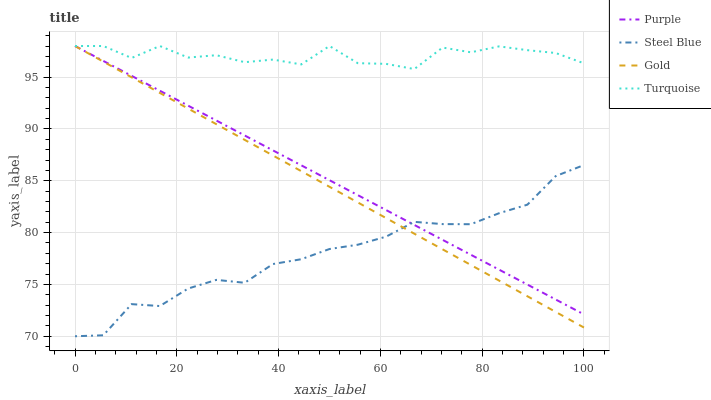Does Steel Blue have the minimum area under the curve?
Answer yes or no. Yes. Does Turquoise have the maximum area under the curve?
Answer yes or no. Yes. Does Turquoise have the minimum area under the curve?
Answer yes or no. No. Does Steel Blue have the maximum area under the curve?
Answer yes or no. No. Is Gold the smoothest?
Answer yes or no. Yes. Is Turquoise the roughest?
Answer yes or no. Yes. Is Steel Blue the smoothest?
Answer yes or no. No. Is Steel Blue the roughest?
Answer yes or no. No. Does Steel Blue have the lowest value?
Answer yes or no. Yes. Does Turquoise have the lowest value?
Answer yes or no. No. Does Gold have the highest value?
Answer yes or no. Yes. Does Steel Blue have the highest value?
Answer yes or no. No. Is Steel Blue less than Turquoise?
Answer yes or no. Yes. Is Turquoise greater than Steel Blue?
Answer yes or no. Yes. Does Turquoise intersect Gold?
Answer yes or no. Yes. Is Turquoise less than Gold?
Answer yes or no. No. Is Turquoise greater than Gold?
Answer yes or no. No. Does Steel Blue intersect Turquoise?
Answer yes or no. No. 